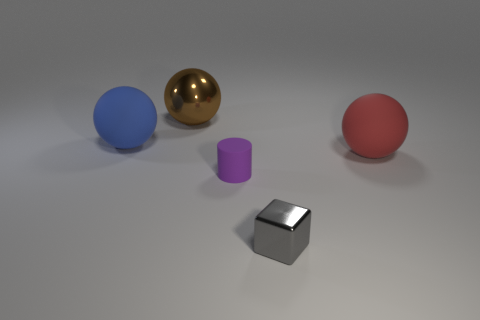How many other things are there of the same color as the small block?
Offer a very short reply. 0. Is the number of big blue rubber objects right of the big metallic thing less than the number of cyan metal cylinders?
Make the answer very short. No. Do the brown thing and the small shiny object have the same shape?
Your answer should be very brief. No. Is there anything else that has the same shape as the gray metallic object?
Your answer should be compact. No. Are any small blue cylinders visible?
Provide a succinct answer. No. Does the tiny shiny object have the same shape as the large rubber thing on the left side of the small matte cylinder?
Your answer should be compact. No. What is the material of the big ball behind the big matte ball behind the big red matte ball?
Make the answer very short. Metal. What is the color of the cylinder?
Ensure brevity in your answer.  Purple. Does the large rubber thing on the left side of the tiny purple cylinder have the same color as the shiny thing in front of the small purple thing?
Ensure brevity in your answer.  No. There is a red thing that is the same shape as the big brown object; what is its size?
Your response must be concise. Large. 